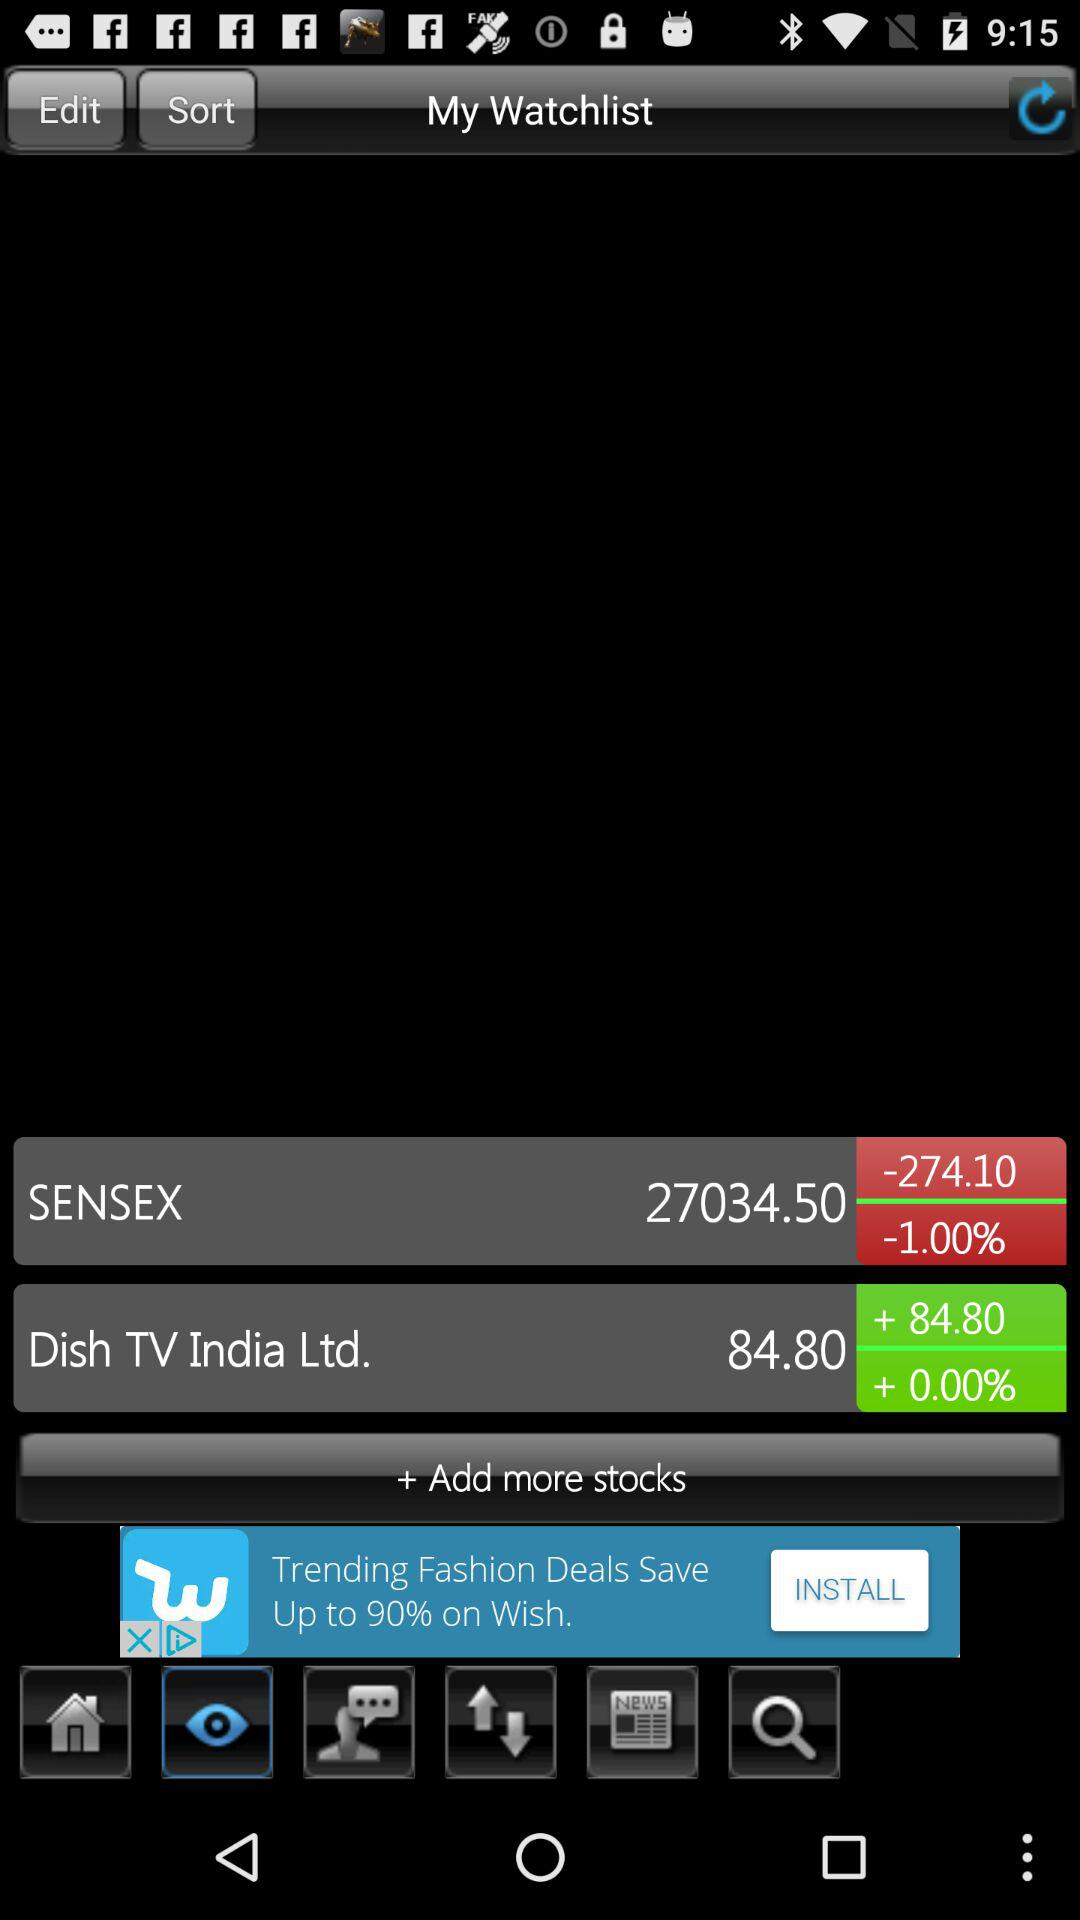What is the percentage change of the first stock?
Answer the question using a single word or phrase. -1.00% 